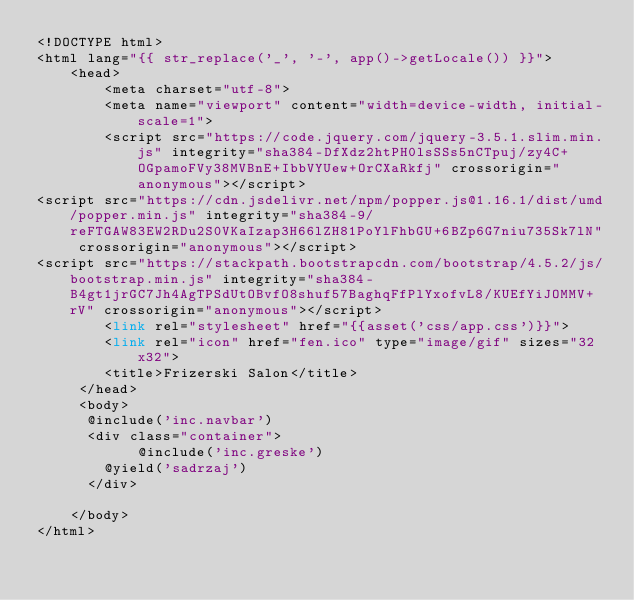<code> <loc_0><loc_0><loc_500><loc_500><_PHP_><!DOCTYPE html>
<html lang="{{ str_replace('_', '-', app()->getLocale()) }}">
    <head>
        <meta charset="utf-8">
        <meta name="viewport" content="width=device-width, initial-scale=1">
        <script src="https://code.jquery.com/jquery-3.5.1.slim.min.js" integrity="sha384-DfXdz2htPH0lsSSs5nCTpuj/zy4C+OGpamoFVy38MVBnE+IbbVYUew+OrCXaRkfj" crossorigin="anonymous"></script>
<script src="https://cdn.jsdelivr.net/npm/popper.js@1.16.1/dist/umd/popper.min.js" integrity="sha384-9/reFTGAW83EW2RDu2S0VKaIzap3H66lZH81PoYlFhbGU+6BZp6G7niu735Sk7lN" crossorigin="anonymous"></script>
<script src="https://stackpath.bootstrapcdn.com/bootstrap/4.5.2/js/bootstrap.min.js" integrity="sha384-B4gt1jrGC7Jh4AgTPSdUtOBvfO8shuf57BaghqFfPlYxofvL8/KUEfYiJOMMV+rV" crossorigin="anonymous"></script>
        <link rel="stylesheet" href="{{asset('css/app.css')}}">
        <link rel="icon" href="fen.ico" type="image/gif" sizes="32x32">
        <title>Frizerski Salon</title>
     </head>
     <body>
     	@include('inc.navbar')
     	<div class="container">
            @include('inc.greske')
     		@yield('sadrzaj')
     	</div>
      
    </body>
</html></code> 